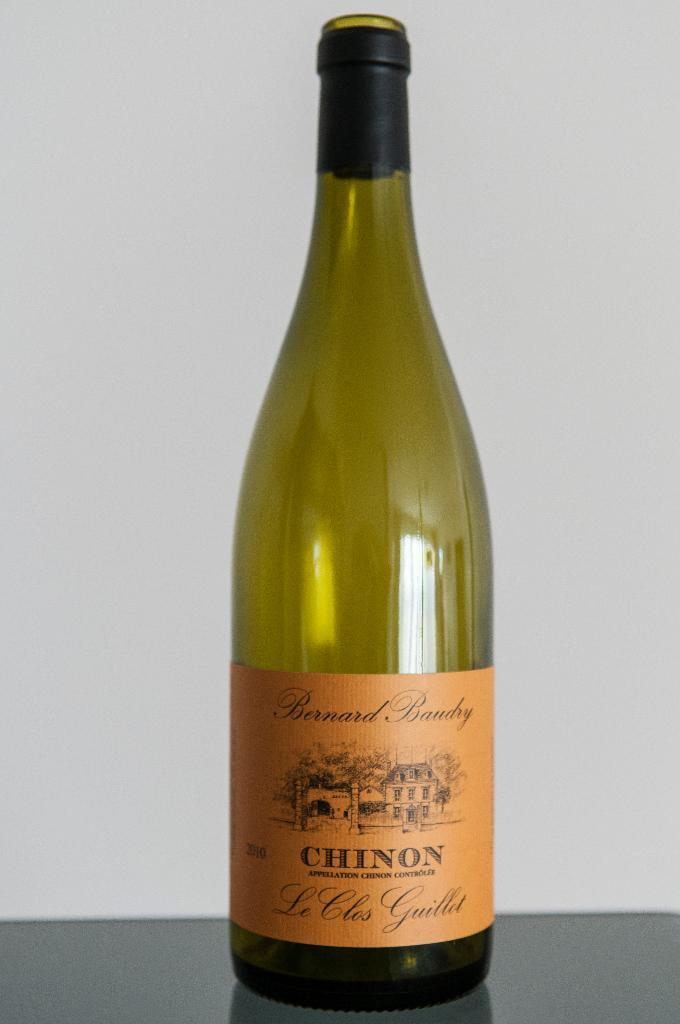<image>
Give a short and clear explanation of the subsequent image. An empty bottle of Chinon wine sits on a table. 